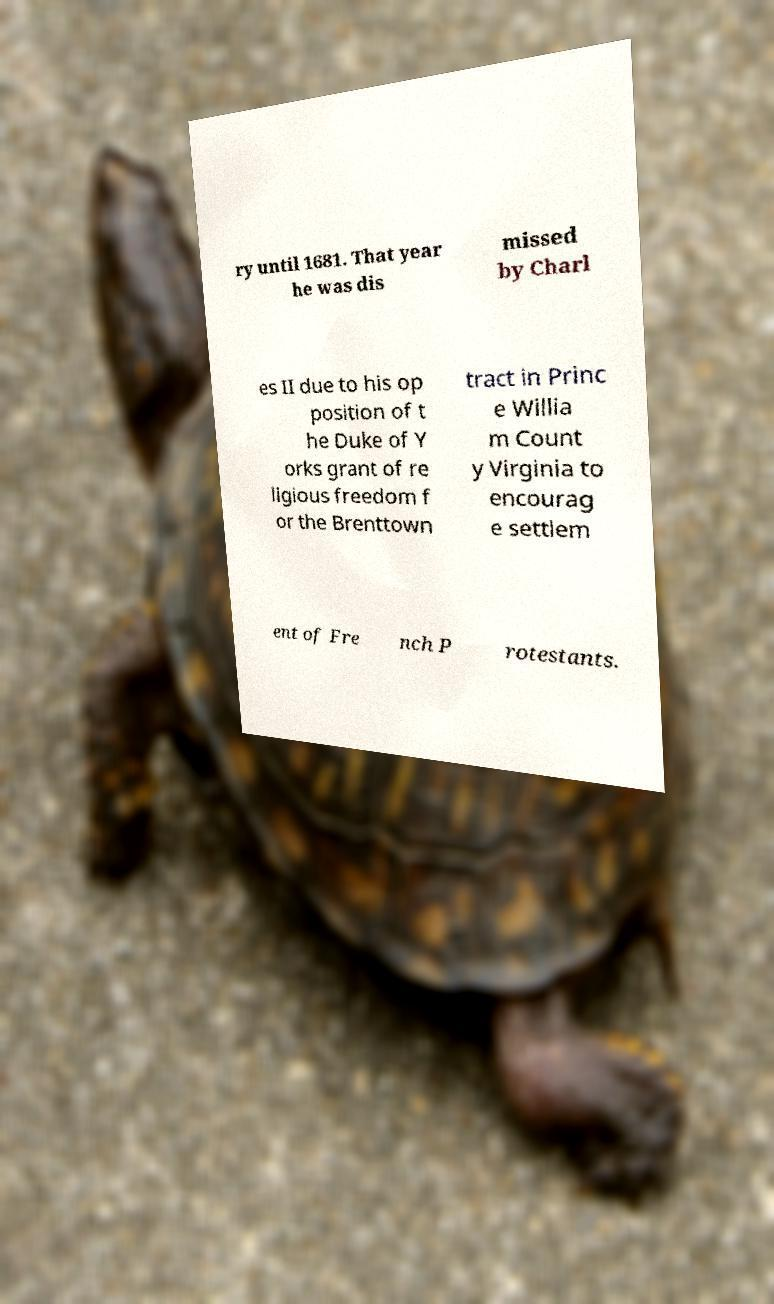For documentation purposes, I need the text within this image transcribed. Could you provide that? ry until 1681. That year he was dis missed by Charl es II due to his op position of t he Duke of Y orks grant of re ligious freedom f or the Brenttown tract in Princ e Willia m Count y Virginia to encourag e settlem ent of Fre nch P rotestants. 